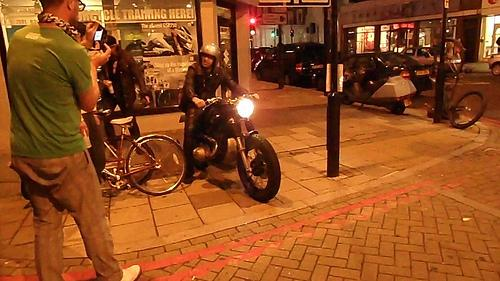Question: where is the motorcycle?
Choices:
A. In the street.
B. On the bridge.
C. On the sidewalk.
D. In the parking lot.
Answer with the letter. Answer: C Question: who is wearing a helmet?
Choices:
A. The man on the motorcycle.
B. The female passenger.
C. The traffic cop.
D. The construction worker.
Answer with the letter. Answer: A Question: what is the man on the left holding?
Choices:
A. A phone.
B. A sandwich.
C. A newspaper.
D. A radio.
Answer with the letter. Answer: A Question: what color are the tires?
Choices:
A. Grey.
B. Brown.
C. Red.
D. Black.
Answer with the letter. Answer: D Question: when was the picture taken?
Choices:
A. During a power outage.
B. At night.
C. In the middle of a storm.
D. In an eclipse.
Answer with the letter. Answer: B Question: where was the picture taken?
Choices:
A. In an office.
B. At the supermarket.
C. On the street.
D. In the mall.
Answer with the letter. Answer: C Question: how many people are there?
Choices:
A. Two.
B. Three.
C. Four.
D. Five.
Answer with the letter. Answer: B 